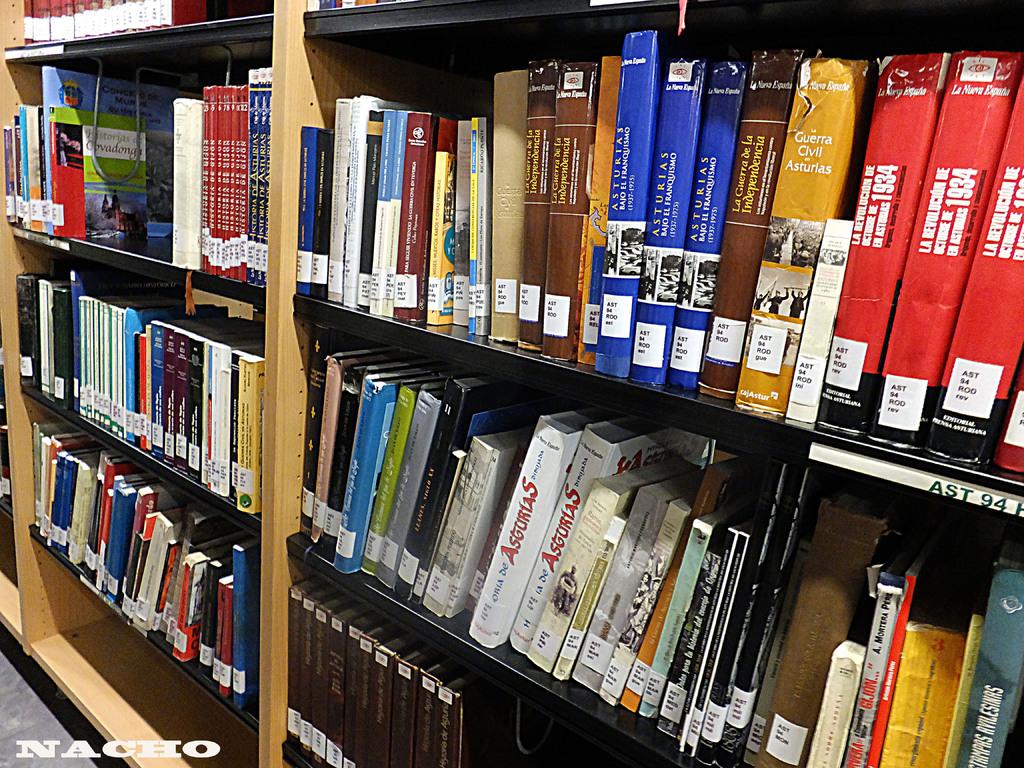What year is on the red book on the right?
Keep it short and to the point. 1934. What is the range of the dewy decimals?
Provide a succinct answer. Unanswerable. 